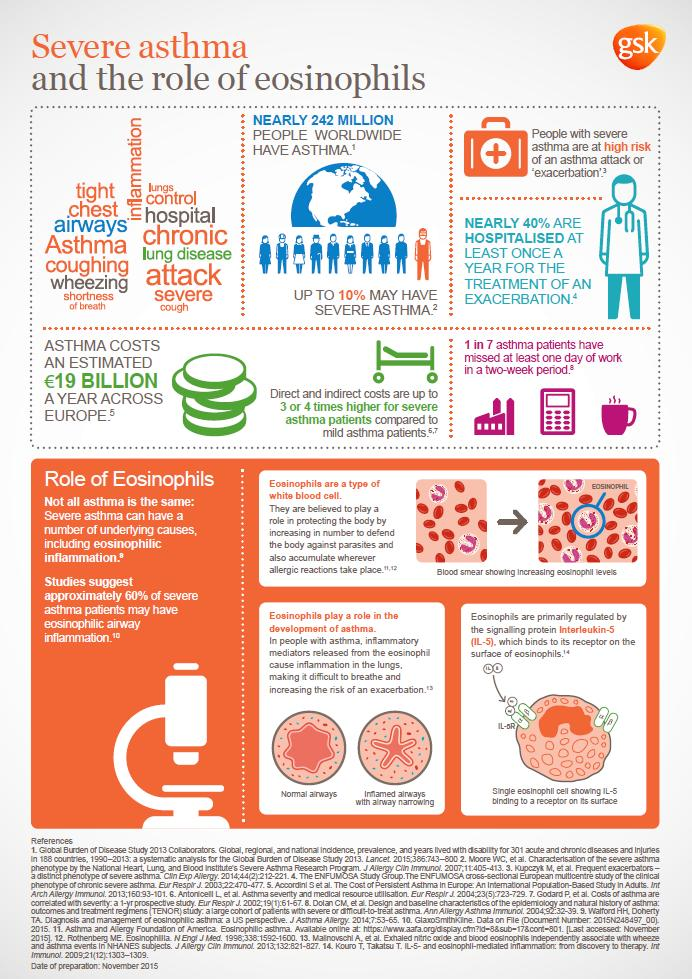Outline some significant characteristics in this image. Approximately 10% of the global population has a severe case of asthma. According to estimates, the worldwide prevalence of asthma is nearly 242 million people. Eosinophils are a type of blood cell that has been linked to the development of asthma. 